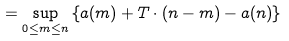Convert formula to latex. <formula><loc_0><loc_0><loc_500><loc_500>= \sup _ { 0 \leq m \leq n } \left \{ a ( m ) + T \cdot ( n - m ) - a ( n ) \right \}</formula> 